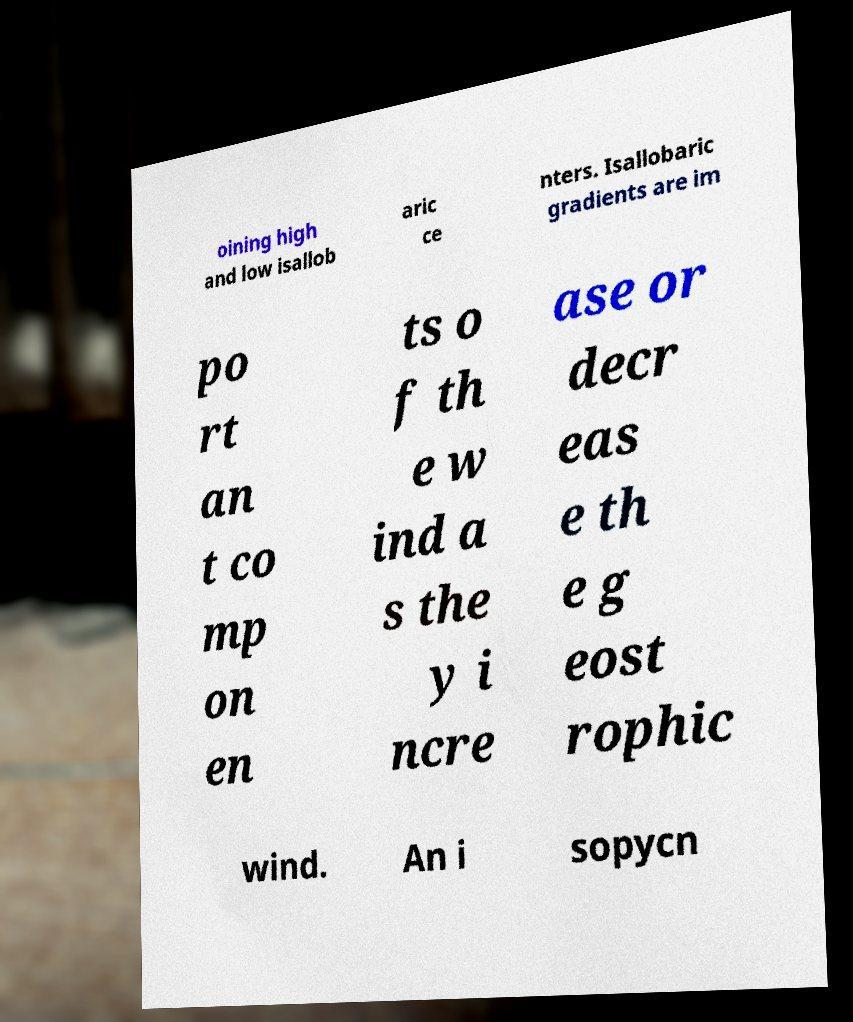Could you extract and type out the text from this image? oining high and low isallob aric ce nters. Isallobaric gradients are im po rt an t co mp on en ts o f th e w ind a s the y i ncre ase or decr eas e th e g eost rophic wind. An i sopycn 